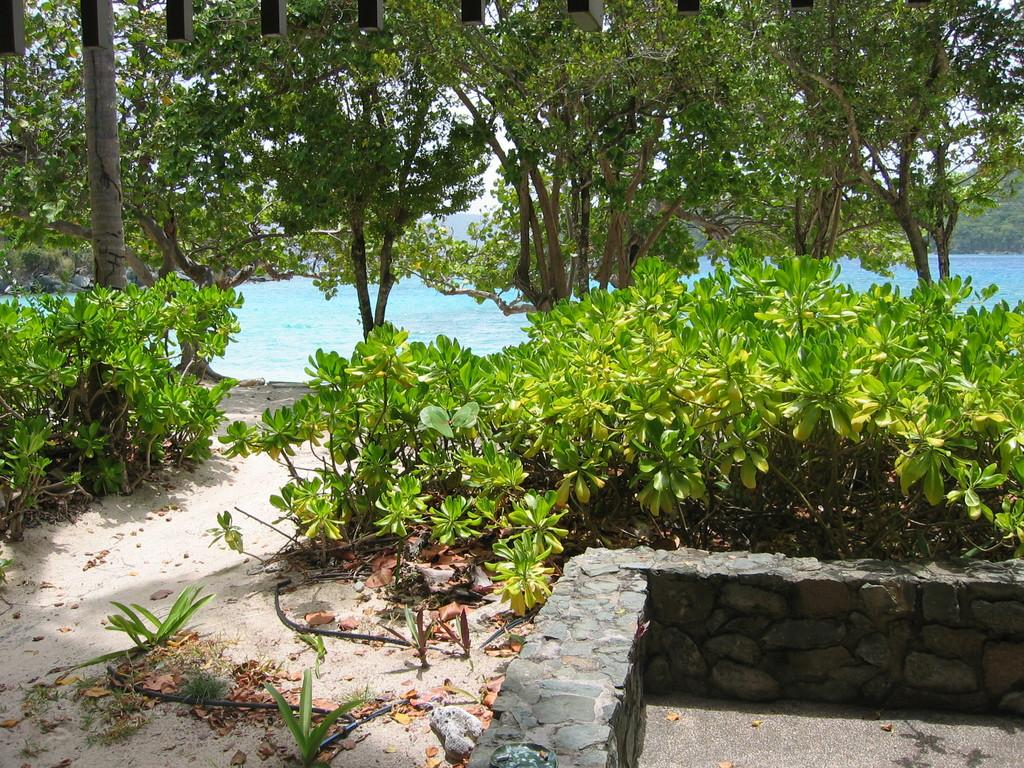What type of landmass is present in the image? There is a small island in the image. What geographical features can be seen on the island? The island has mountains and a small empty pond. What type of vegetation is present on the island? There are trees and plants on the island. What type of terrain can be found on the island? The island has sand. What type of jewel is hidden in the small empty pond on the island? There is no mention of a jewel in the image, and the pond is described as empty. 